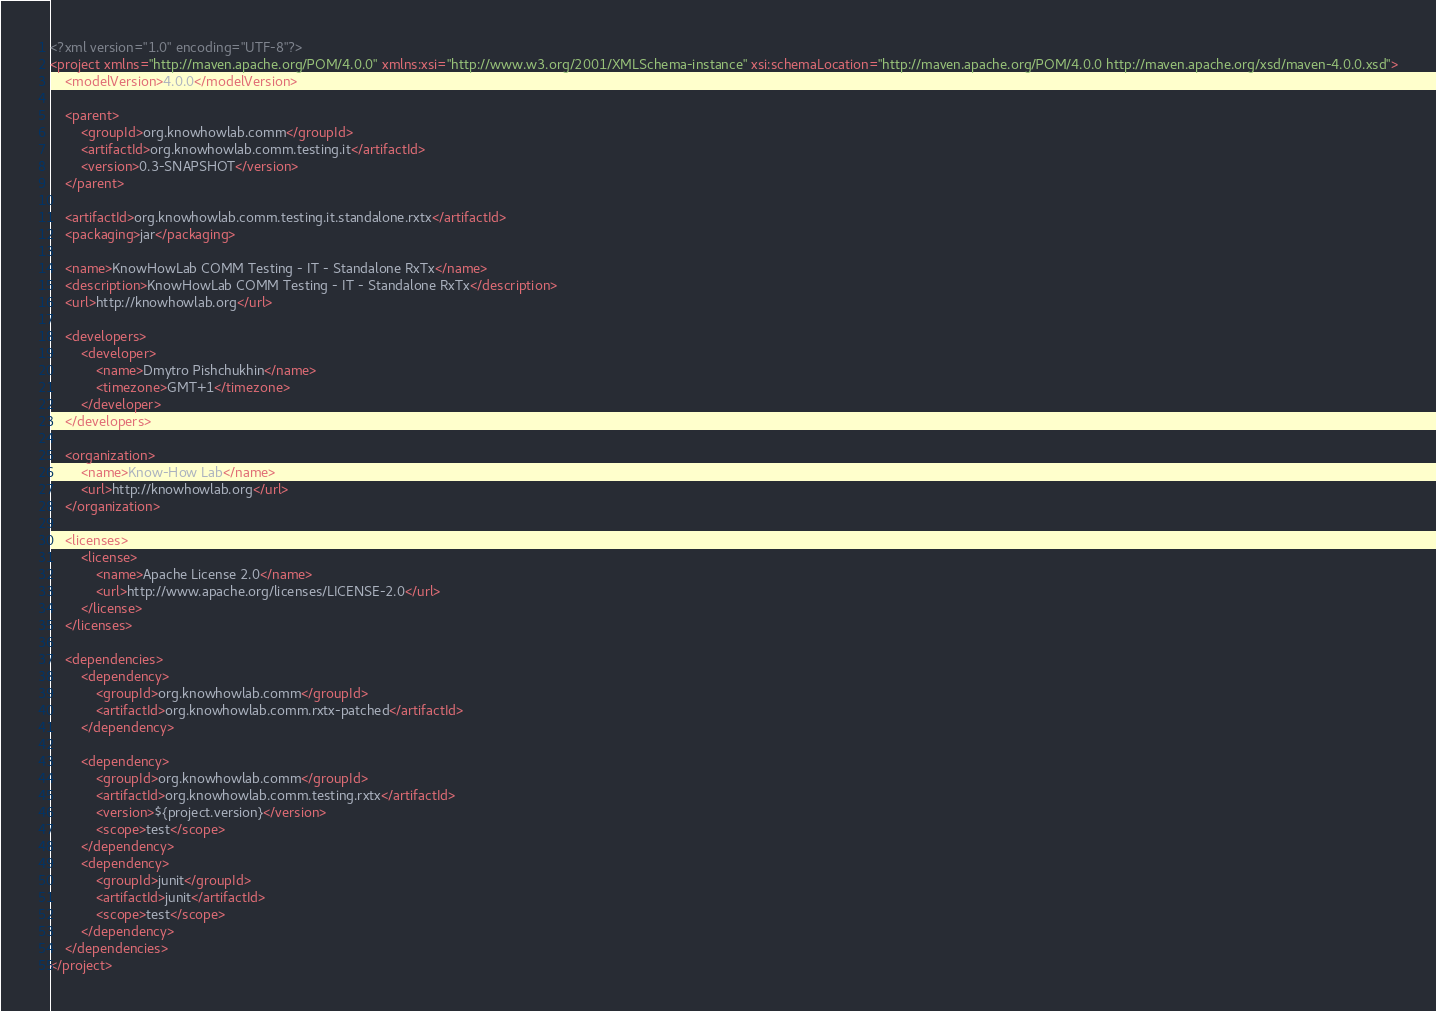<code> <loc_0><loc_0><loc_500><loc_500><_XML_><?xml version="1.0" encoding="UTF-8"?>
<project xmlns="http://maven.apache.org/POM/4.0.0" xmlns:xsi="http://www.w3.org/2001/XMLSchema-instance" xsi:schemaLocation="http://maven.apache.org/POM/4.0.0 http://maven.apache.org/xsd/maven-4.0.0.xsd">
    <modelVersion>4.0.0</modelVersion>

    <parent>
        <groupId>org.knowhowlab.comm</groupId>
        <artifactId>org.knowhowlab.comm.testing.it</artifactId>
        <version>0.3-SNAPSHOT</version>
    </parent>

    <artifactId>org.knowhowlab.comm.testing.it.standalone.rxtx</artifactId>
    <packaging>jar</packaging>

    <name>KnowHowLab COMM Testing - IT - Standalone RxTx</name>
    <description>KnowHowLab COMM Testing - IT - Standalone RxTx</description>
    <url>http://knowhowlab.org</url>

    <developers>
        <developer>
            <name>Dmytro Pishchukhin</name>
            <timezone>GMT+1</timezone>
        </developer>
    </developers>

    <organization>
        <name>Know-How Lab</name>
        <url>http://knowhowlab.org</url>
    </organization>

    <licenses>
        <license>
            <name>Apache License 2.0</name>
            <url>http://www.apache.org/licenses/LICENSE-2.0</url>
        </license>
    </licenses>

    <dependencies>
        <dependency>
            <groupId>org.knowhowlab.comm</groupId>
            <artifactId>org.knowhowlab.comm.rxtx-patched</artifactId>
        </dependency>

        <dependency>
            <groupId>org.knowhowlab.comm</groupId>
            <artifactId>org.knowhowlab.comm.testing.rxtx</artifactId>
            <version>${project.version}</version>
            <scope>test</scope>
        </dependency>
        <dependency>
            <groupId>junit</groupId>
            <artifactId>junit</artifactId>
            <scope>test</scope>
        </dependency>
    </dependencies>
</project></code> 